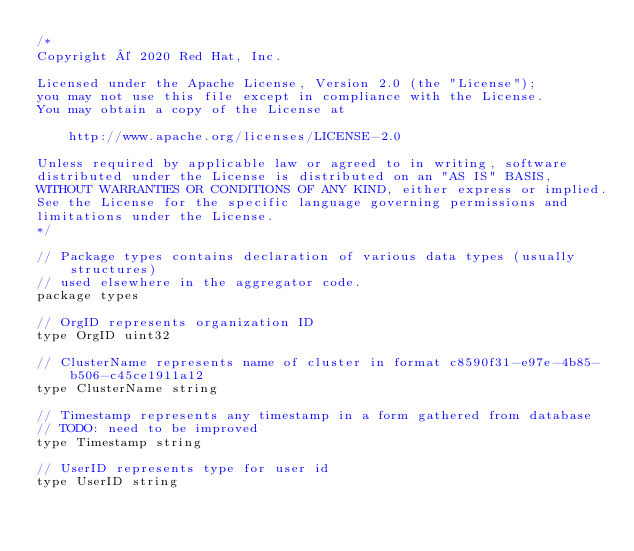<code> <loc_0><loc_0><loc_500><loc_500><_Go_>/*
Copyright © 2020 Red Hat, Inc.

Licensed under the Apache License, Version 2.0 (the "License");
you may not use this file except in compliance with the License.
You may obtain a copy of the License at

    http://www.apache.org/licenses/LICENSE-2.0

Unless required by applicable law or agreed to in writing, software
distributed under the License is distributed on an "AS IS" BASIS,
WITHOUT WARRANTIES OR CONDITIONS OF ANY KIND, either express or implied.
See the License for the specific language governing permissions and
limitations under the License.
*/

// Package types contains declaration of various data types (usually structures)
// used elsewhere in the aggregator code.
package types

// OrgID represents organization ID
type OrgID uint32

// ClusterName represents name of cluster in format c8590f31-e97e-4b85-b506-c45ce1911a12
type ClusterName string

// Timestamp represents any timestamp in a form gathered from database
// TODO: need to be improved
type Timestamp string

// UserID represents type for user id
type UserID string
</code> 